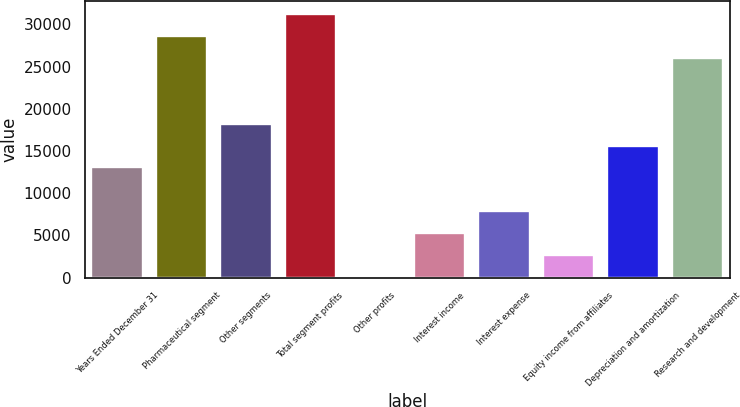Convert chart to OTSL. <chart><loc_0><loc_0><loc_500><loc_500><bar_chart><fcel>Years Ended December 31<fcel>Pharmaceutical segment<fcel>Other segments<fcel>Total segment profits<fcel>Other profits<fcel>Interest income<fcel>Interest expense<fcel>Equity income from affiliates<fcel>Depreciation and amortization<fcel>Research and development<nl><fcel>13047.5<fcel>28628.9<fcel>18241.3<fcel>31225.8<fcel>63<fcel>5256.8<fcel>7853.7<fcel>2659.9<fcel>15644.4<fcel>26032<nl></chart> 